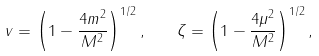Convert formula to latex. <formula><loc_0><loc_0><loc_500><loc_500>v = \left ( 1 - \frac { 4 m ^ { 2 } } { M ^ { 2 } } \right ) ^ { 1 / 2 } , \quad \zeta = \left ( 1 - \frac { 4 \mu ^ { 2 } } { M ^ { 2 } } \right ) ^ { 1 / 2 } ,</formula> 